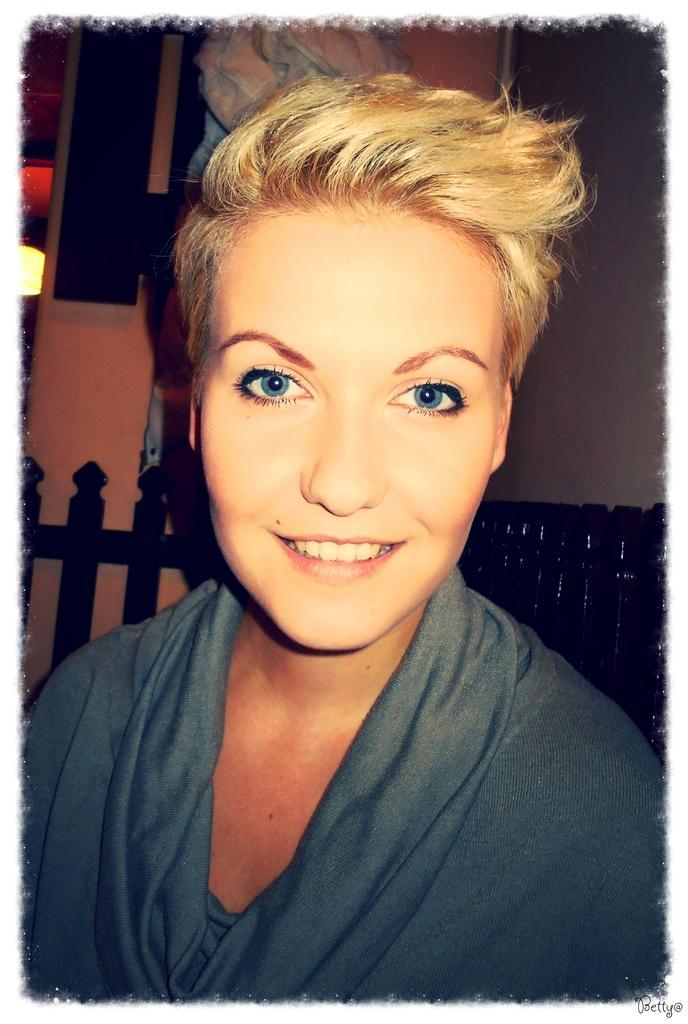In one or two sentences, can you explain what this image depicts? In the center of the image we can see one person is smiling. In the background there is a wall and a few other objects. 